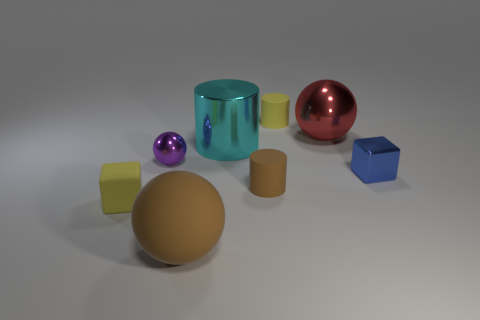How many other objects are the same shape as the big cyan object?
Make the answer very short. 2. There is a sphere that is right of the small purple thing and behind the tiny shiny block; what is its color?
Make the answer very short. Red. What is the color of the metal block?
Keep it short and to the point. Blue. Is the material of the big cyan object the same as the tiny yellow thing that is on the right side of the large brown matte thing?
Provide a short and direct response. No. The small brown thing that is the same material as the yellow cylinder is what shape?
Provide a short and direct response. Cylinder. There is a shiny cylinder that is the same size as the brown rubber ball; what is its color?
Your answer should be very brief. Cyan. There is a yellow rubber object that is behind the blue object; does it have the same size as the small purple object?
Provide a short and direct response. Yes. How many tiny blue shiny objects are there?
Your answer should be very brief. 1. How many cylinders are either cyan shiny objects or tiny things?
Provide a succinct answer. 3. There is a red object that is behind the big brown ball; how many small matte things are to the left of it?
Offer a very short reply. 3. 